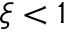Convert formula to latex. <formula><loc_0><loc_0><loc_500><loc_500>\xi < 1</formula> 